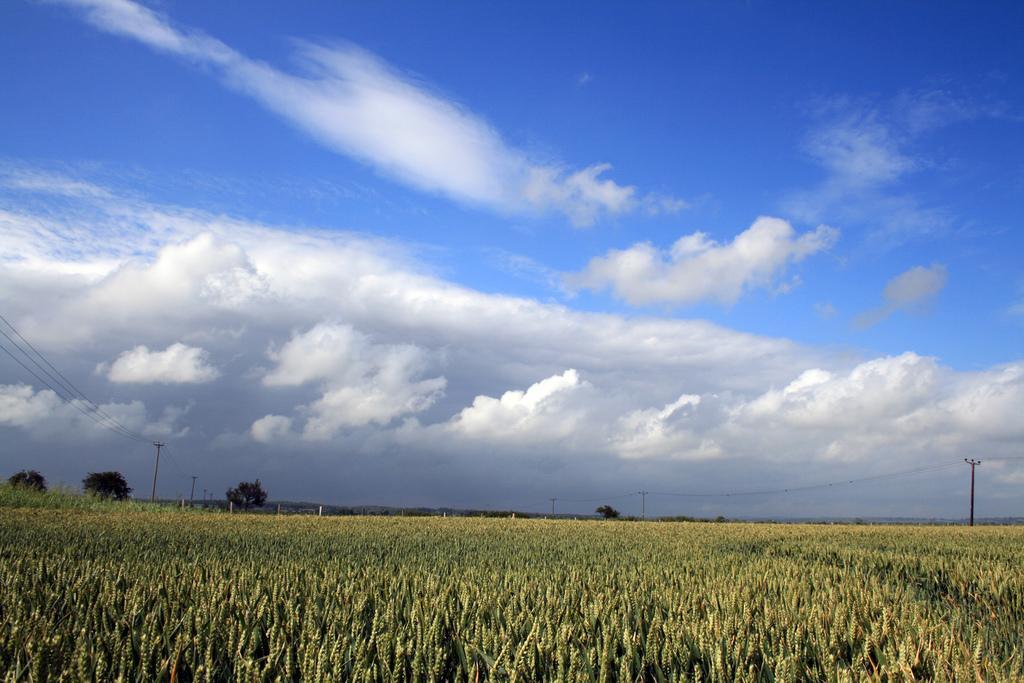How would you summarize this image in a sentence or two? At the bottom of the image there is a field. In the background there are trees and poles. We can see wires, hills and sky. 